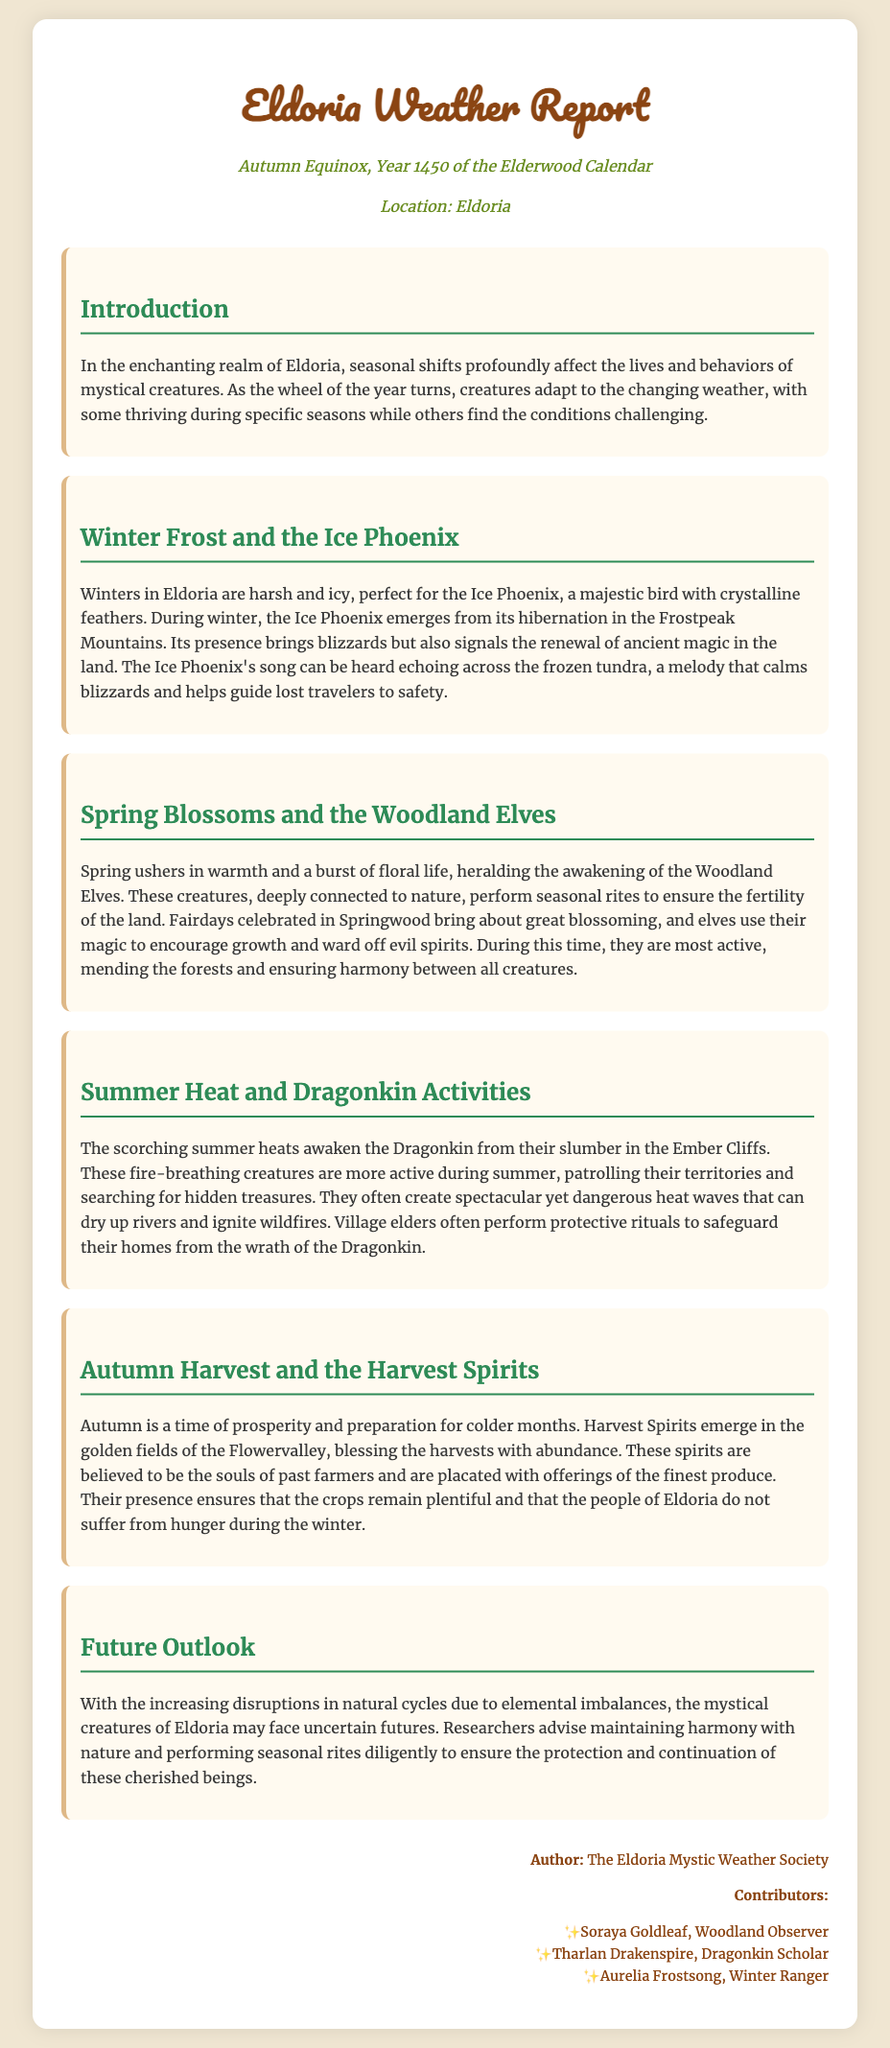What is the title of the report? The title of the report is prominently displayed at the top of the document.
Answer: Eldoria Weather Report What creatures emerge during Winter? The document identifies creatures associated with each season, and for Winter, it specifically mentions one.
Answer: Ice Phoenix Which spirits are active during Autumn? The report discusses the significance of different creatures in each season, including Autumn.
Answer: Harvest Spirits What is the purpose of Woodland Elves in Spring? The section about Spring describes the actions and role of the Woodland Elves during this season.
Answer: Ensure the fertility of the land What do Dragonkin create during Summer? The report mentions an outcome of Dragonkin activity during summer, indicating their impact.
Answer: Heat waves How do the Harvest Spirits bless the land? This question requires understanding the text about Harvest Spirits in Autumn and their role.
Answer: By blessing the harvests with abundance What year is mentioned in the report? The date provides the context of the weather report and its relevance in the Eldoria timeline.
Answer: 1450 Who authored the report? The credits section lists the origin of the report, giving credit to the author.
Answer: The Eldoria Mystic Weather Society 